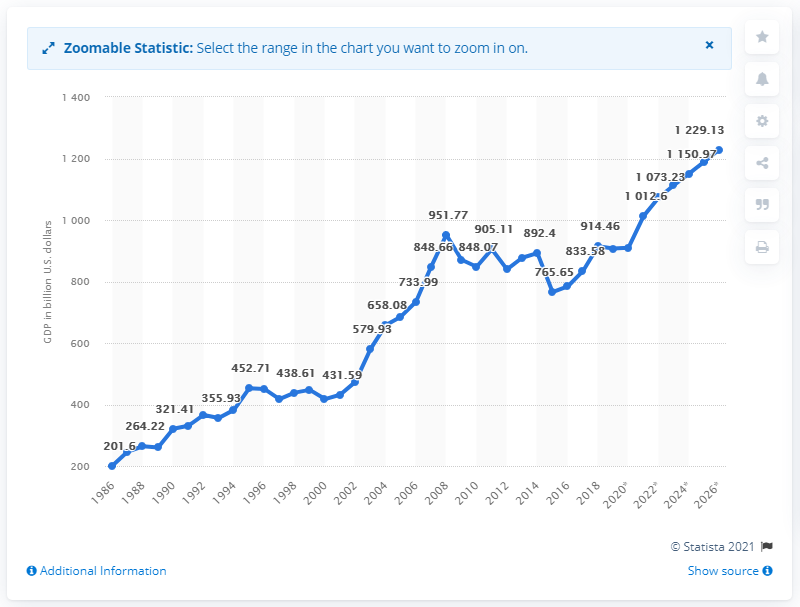Give some essential details in this illustration. In 2019, the Gross Domestic Product (GDP) of the Netherlands was approximately 909.5 billion US dollars. 